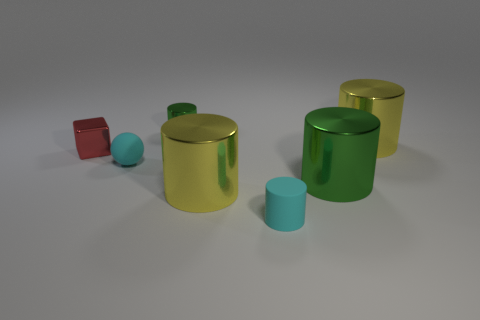Subtract all green shiny cylinders. How many cylinders are left? 3 Subtract all blue balls. How many yellow cylinders are left? 2 Subtract all yellow cylinders. How many cylinders are left? 3 Add 1 small gray cylinders. How many objects exist? 8 Subtract all cyan cylinders. Subtract all green spheres. How many cylinders are left? 4 Subtract 0 gray blocks. How many objects are left? 7 Subtract all balls. How many objects are left? 6 Subtract all big green metallic blocks. Subtract all tiny balls. How many objects are left? 6 Add 4 large green shiny cylinders. How many large green shiny cylinders are left? 5 Add 7 big balls. How many big balls exist? 7 